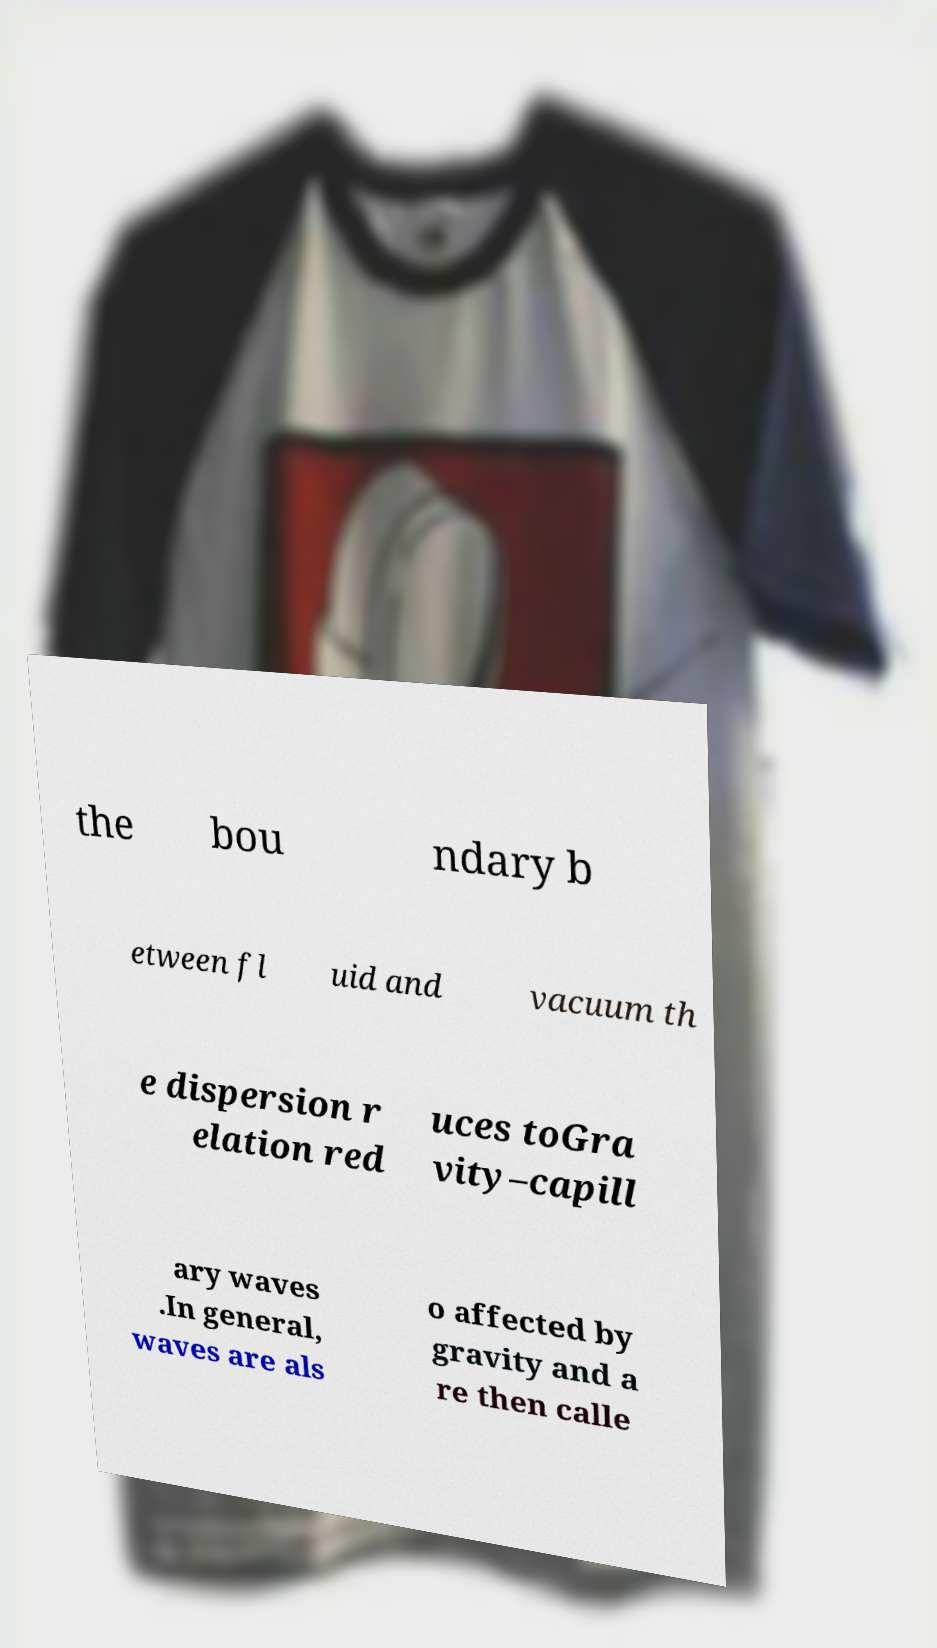I need the written content from this picture converted into text. Can you do that? the bou ndary b etween fl uid and vacuum th e dispersion r elation red uces toGra vity–capill ary waves .In general, waves are als o affected by gravity and a re then calle 